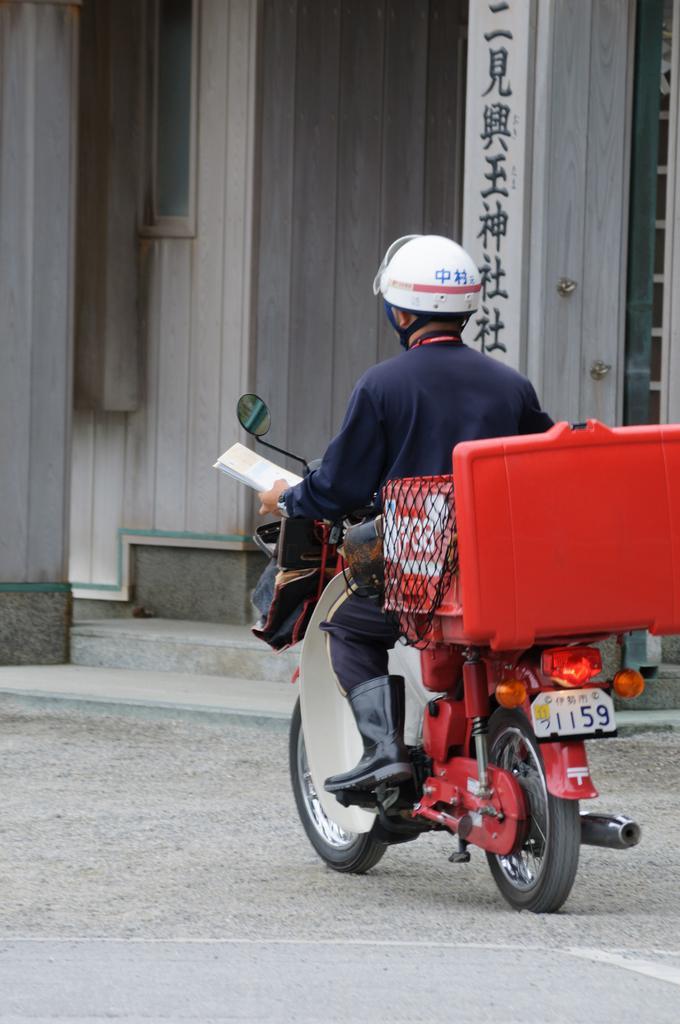How would you summarize this image in a sentence or two? In the picture we can see a man driving a motor cycle, on the motorcycle we can find a box and man is wearing a helmet with black shoe. In the background we can find a wall with written something in a chinese language. 